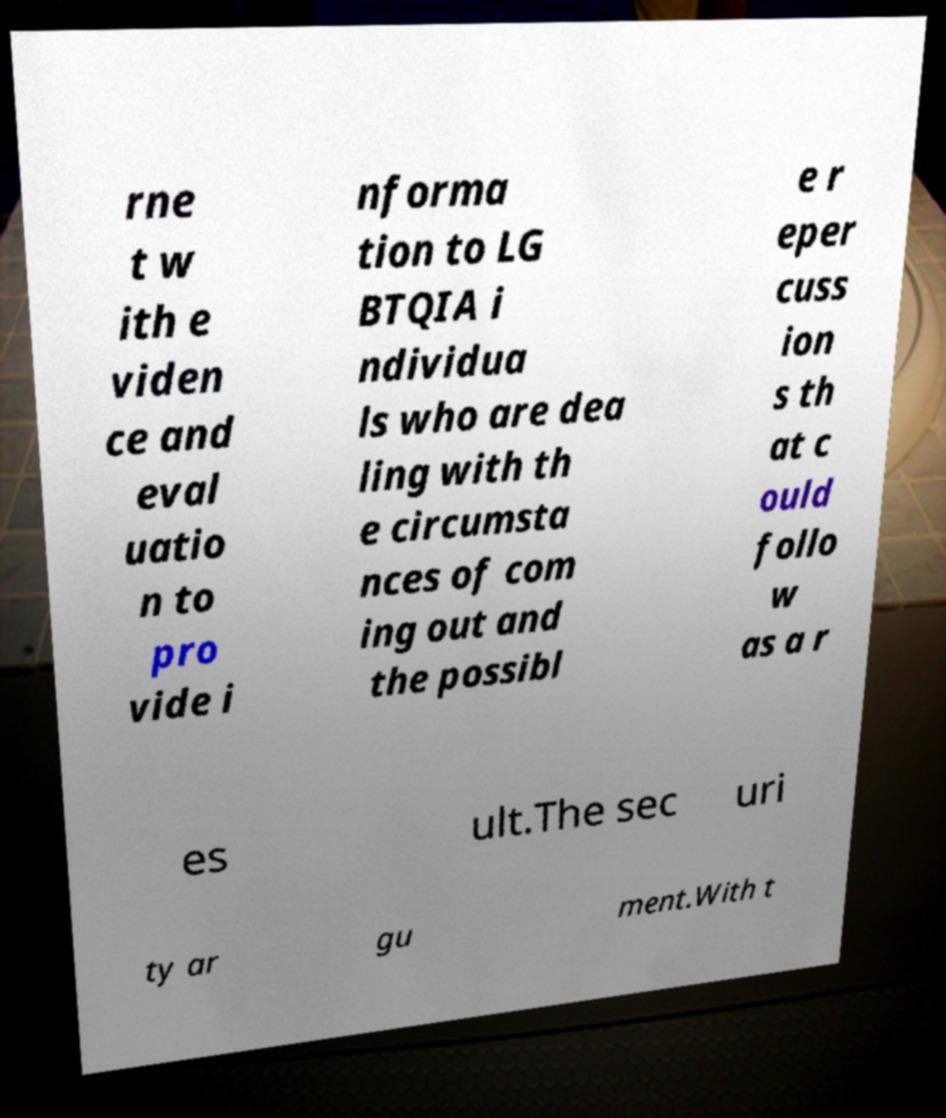Could you extract and type out the text from this image? rne t w ith e viden ce and eval uatio n to pro vide i nforma tion to LG BTQIA i ndividua ls who are dea ling with th e circumsta nces of com ing out and the possibl e r eper cuss ion s th at c ould follo w as a r es ult.The sec uri ty ar gu ment.With t 